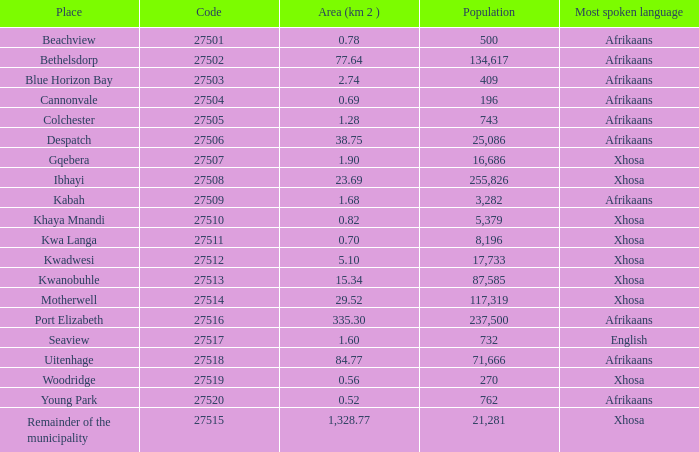What is the aggregate code number for spots with a population larger than 87,585? 4.0. 